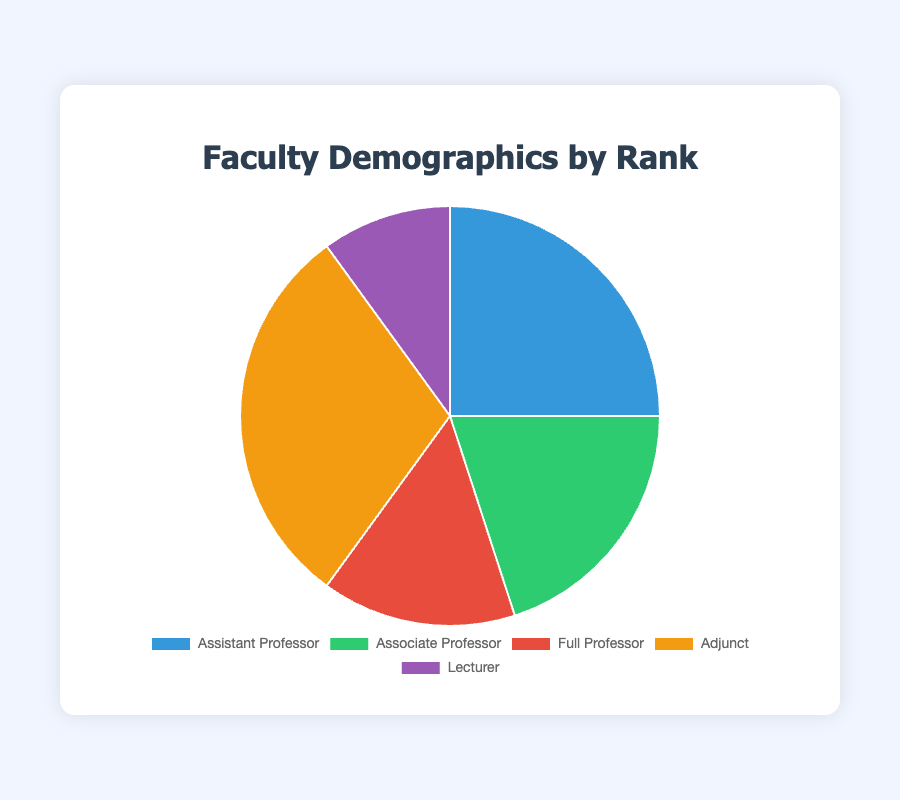Which rank has the highest percentage of faculty members? Adjunct has 30 members, which is the highest among all categories.
Answer: Adjunct Which rank has the lowest percentage of faculty members? Lecturer has 10 members, which is the smallest number of any rank.
Answer: Lecturer How many more Assistant Professors are there than Lecturers? There are 25 Assistant Professors and 10 Lecturers. The difference is 25 - 10 = 15.
Answer: 15 What is the total percentage of faculty members who are either Associate Professors or Full Professors? The number of Associate Professors and Full Professors is 20 and 15 respectively. The total is 20 + 15 = 35.
Answer: 35 Which two ranks have equal numbers of faculty members when summed together equal the number of Adjuncts? The sum of Associate Professors and Lecturers is 20 + 10 = 30, which equals the number of Adjuncts.
Answer: Associate Professor and Lecturer What is the average number of faculty members per rank? The total number of faculty members is 25 + 20 + 15 + 30 + 10 = 100. There are 5 ranks, so the average is 100 / 5 = 20.
Answer: 20 Compare the number of Full Professors to the number of Lecturers and describe the visual difference in the pie chart. There are 15 Full Professors and 10 Lecturers. The Full Professors' section of the pie chart is larger than the Lecturers' section and is represented by a different color.
Answer: Full Professors are more than Lecturers What rank follows Adjunct in having the second largest percentage of faculty members? Assistant Professors have 25 members, making them the second largest group after Adjuncts.
Answer: Assistant Professor 